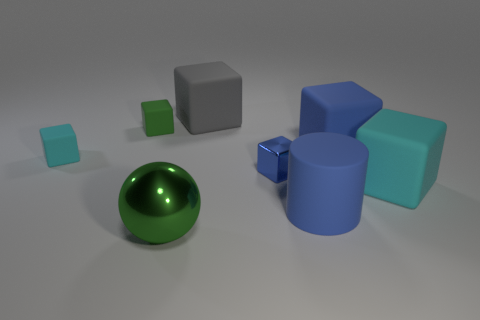Subtract all green blocks. How many blocks are left? 5 Subtract all green cylinders. How many blue blocks are left? 2 Add 1 blue matte cylinders. How many objects exist? 9 Subtract all cyan cubes. How many cubes are left? 4 Subtract 1 blocks. How many blocks are left? 5 Subtract all blocks. How many objects are left? 2 Subtract all yellow cubes. Subtract all purple spheres. How many cubes are left? 6 Subtract all large gray metallic cylinders. Subtract all large cyan rubber blocks. How many objects are left? 7 Add 7 large blue rubber things. How many large blue rubber things are left? 9 Add 8 small metal objects. How many small metal objects exist? 9 